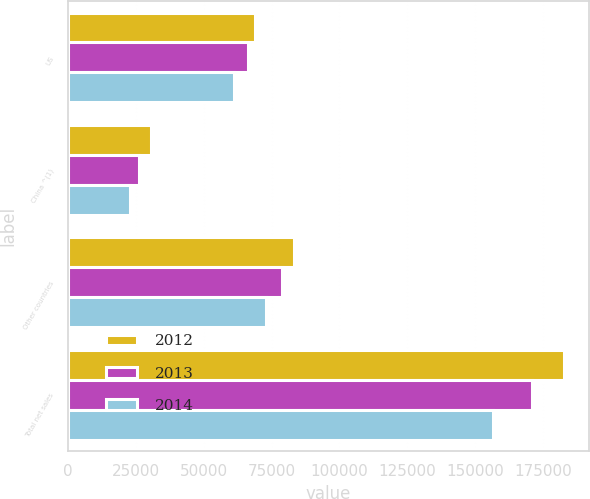<chart> <loc_0><loc_0><loc_500><loc_500><stacked_bar_chart><ecel><fcel>US<fcel>China ^(1)<fcel>Other countries<fcel>Total net sales<nl><fcel>2012<fcel>68909<fcel>30638<fcel>83248<fcel>182795<nl><fcel>2013<fcel>66197<fcel>25946<fcel>78767<fcel>170910<nl><fcel>2014<fcel>60949<fcel>22797<fcel>72762<fcel>156508<nl></chart> 